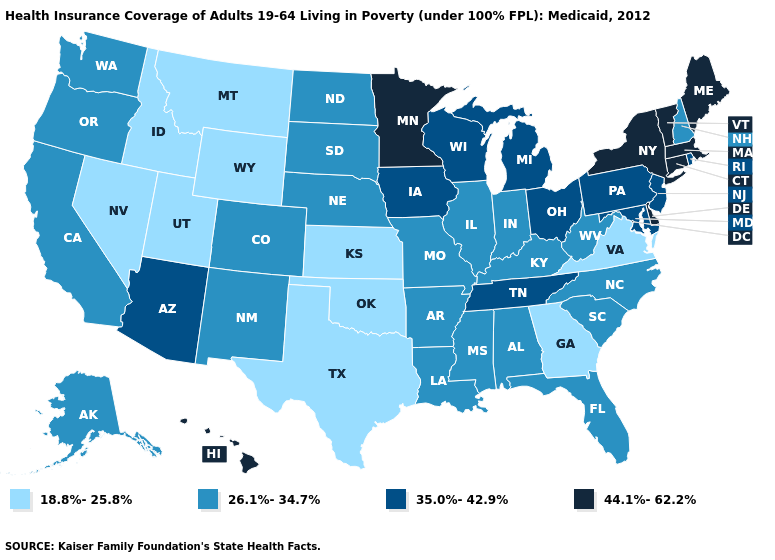Which states hav the highest value in the Northeast?
Short answer required. Connecticut, Maine, Massachusetts, New York, Vermont. What is the highest value in the USA?
Quick response, please. 44.1%-62.2%. What is the lowest value in the Northeast?
Short answer required. 26.1%-34.7%. What is the value of Tennessee?
Be succinct. 35.0%-42.9%. Is the legend a continuous bar?
Short answer required. No. What is the lowest value in the South?
Quick response, please. 18.8%-25.8%. Among the states that border Colorado , which have the highest value?
Write a very short answer. Arizona. Does Maryland have the lowest value in the USA?
Answer briefly. No. Does West Virginia have the lowest value in the South?
Be succinct. No. Does Nevada have the highest value in the West?
Give a very brief answer. No. What is the value of Iowa?
Keep it brief. 35.0%-42.9%. Does the map have missing data?
Short answer required. No. Name the states that have a value in the range 44.1%-62.2%?
Short answer required. Connecticut, Delaware, Hawaii, Maine, Massachusetts, Minnesota, New York, Vermont. Does Nevada have a lower value than Wyoming?
Give a very brief answer. No. Among the states that border Iowa , which have the highest value?
Quick response, please. Minnesota. 